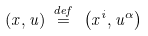<formula> <loc_0><loc_0><loc_500><loc_500>( x , u ) \ { \stackrel { d e f } { = } } \ \left ( x ^ { i } , u ^ { \alpha } \right )</formula> 